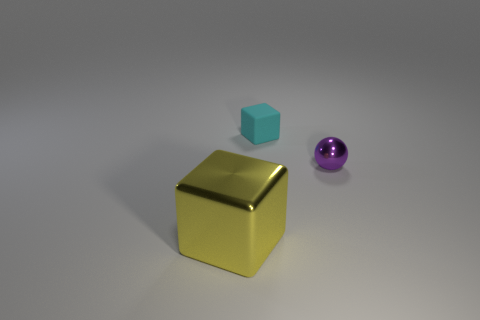Is the number of rubber things that are on the right side of the large yellow metal thing less than the number of cyan objects?
Offer a terse response. No. What size is the yellow metallic cube?
Your answer should be compact. Large. How many objects have the same color as the tiny shiny ball?
Your response must be concise. 0. Is there a thing that is right of the cube that is in front of the metal object on the right side of the tiny cyan object?
Keep it short and to the point. Yes. The rubber object that is the same size as the shiny sphere is what shape?
Make the answer very short. Cube. How many big things are either cubes or cyan cubes?
Your answer should be very brief. 1. There is a tiny object that is made of the same material as the big thing; what is its color?
Give a very brief answer. Purple. Do the small object that is behind the tiny shiny thing and the shiny object on the left side of the tiny cyan thing have the same shape?
Your answer should be very brief. Yes. How many metal objects are either large yellow cubes or small cubes?
Offer a terse response. 1. Is there any other thing that is the same shape as the small purple object?
Ensure brevity in your answer.  No. 